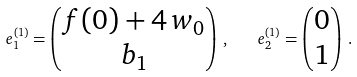<formula> <loc_0><loc_0><loc_500><loc_500>e _ { 1 } ^ { ( 1 ) } = \begin{pmatrix} f ( 0 ) + 4 \, w _ { 0 } \\ b _ { 1 } \end{pmatrix} \, , \quad e _ { 2 } ^ { ( 1 ) } = \begin{pmatrix} 0 \\ 1 \end{pmatrix} \, .</formula> 